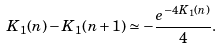Convert formula to latex. <formula><loc_0><loc_0><loc_500><loc_500>K _ { 1 } ( n ) - K _ { 1 } ( n + 1 ) \simeq - \frac { e ^ { - 4 K _ { 1 } ( n ) } } { 4 } .</formula> 